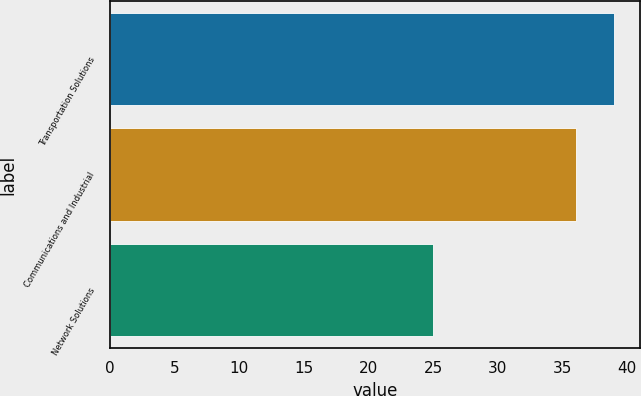Convert chart to OTSL. <chart><loc_0><loc_0><loc_500><loc_500><bar_chart><fcel>Transportation Solutions<fcel>Communications and Industrial<fcel>Network Solutions<nl><fcel>39<fcel>36<fcel>25<nl></chart> 